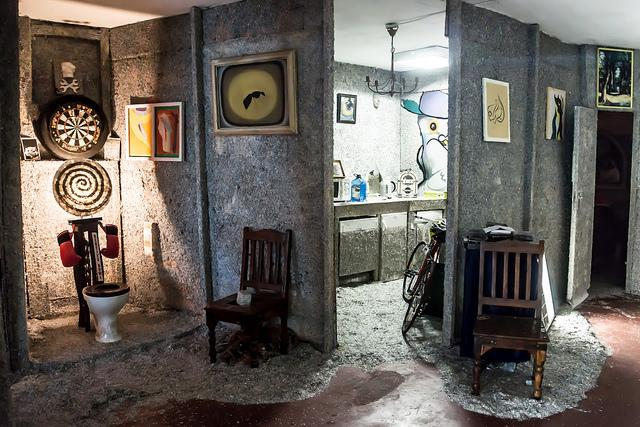Who most likely lives here?

Choices:
A) eccentric
B) pilot
C) caveman
D) criminal eccentric 